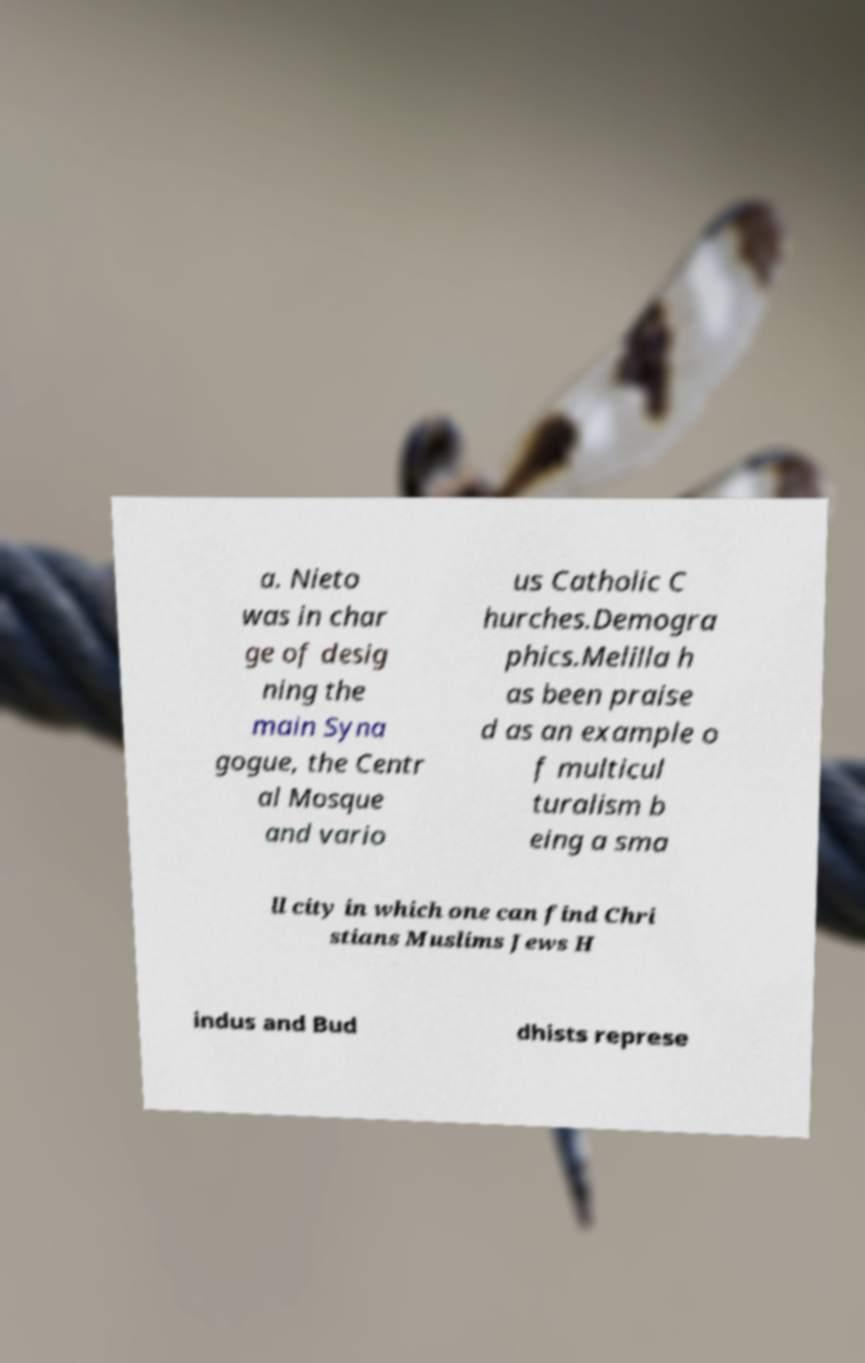Can you accurately transcribe the text from the provided image for me? a. Nieto was in char ge of desig ning the main Syna gogue, the Centr al Mosque and vario us Catholic C hurches.Demogra phics.Melilla h as been praise d as an example o f multicul turalism b eing a sma ll city in which one can find Chri stians Muslims Jews H indus and Bud dhists represe 